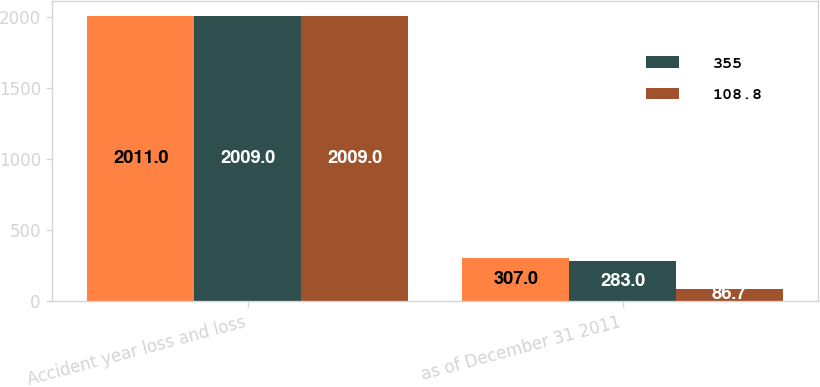Convert chart. <chart><loc_0><loc_0><loc_500><loc_500><stacked_bar_chart><ecel><fcel>Accident year loss and loss<fcel>as of December 31 2011<nl><fcel>nan<fcel>2011<fcel>307<nl><fcel>355<fcel>2009<fcel>283<nl><fcel>108.8<fcel>2009<fcel>86.7<nl></chart> 